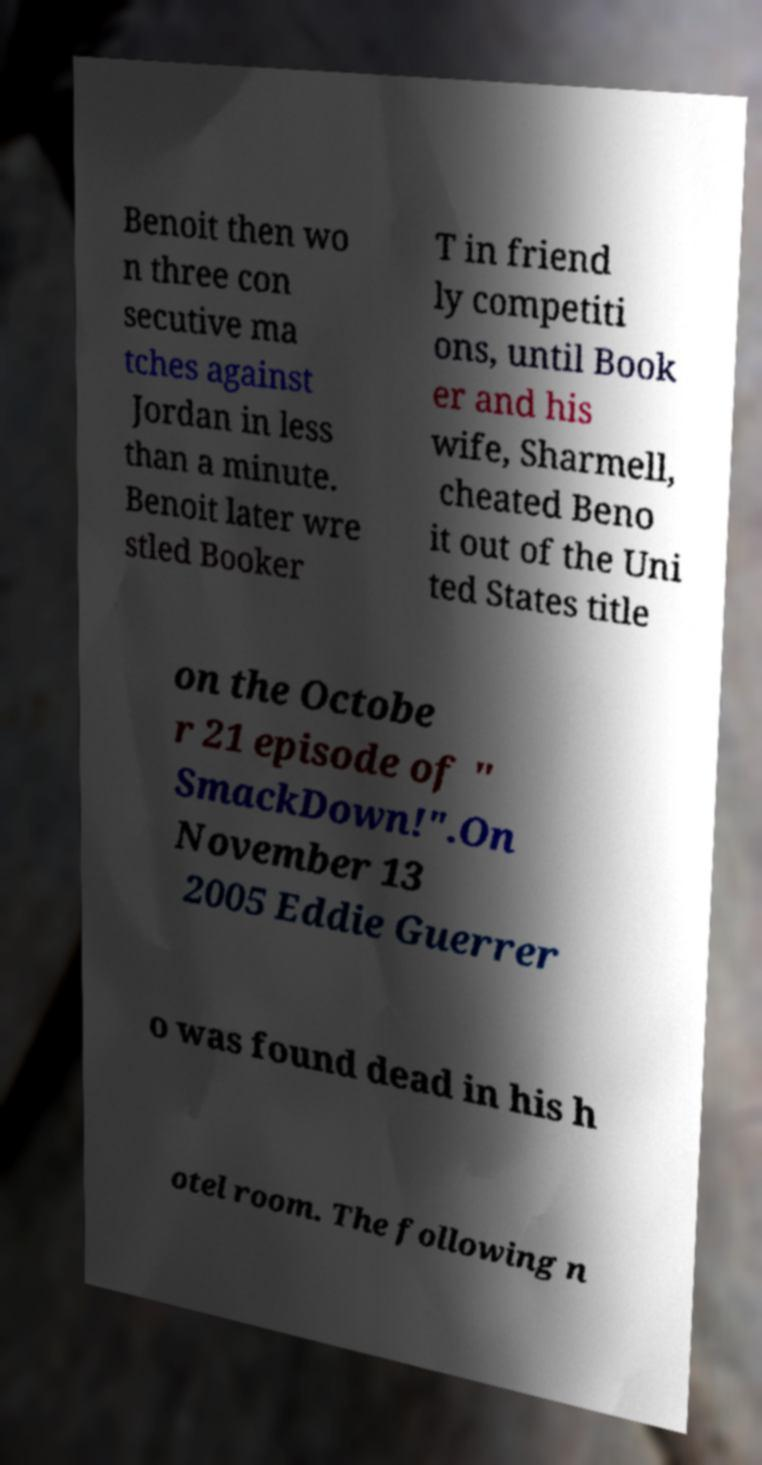What messages or text are displayed in this image? I need them in a readable, typed format. Benoit then wo n three con secutive ma tches against Jordan in less than a minute. Benoit later wre stled Booker T in friend ly competiti ons, until Book er and his wife, Sharmell, cheated Beno it out of the Uni ted States title on the Octobe r 21 episode of " SmackDown!".On November 13 2005 Eddie Guerrer o was found dead in his h otel room. The following n 